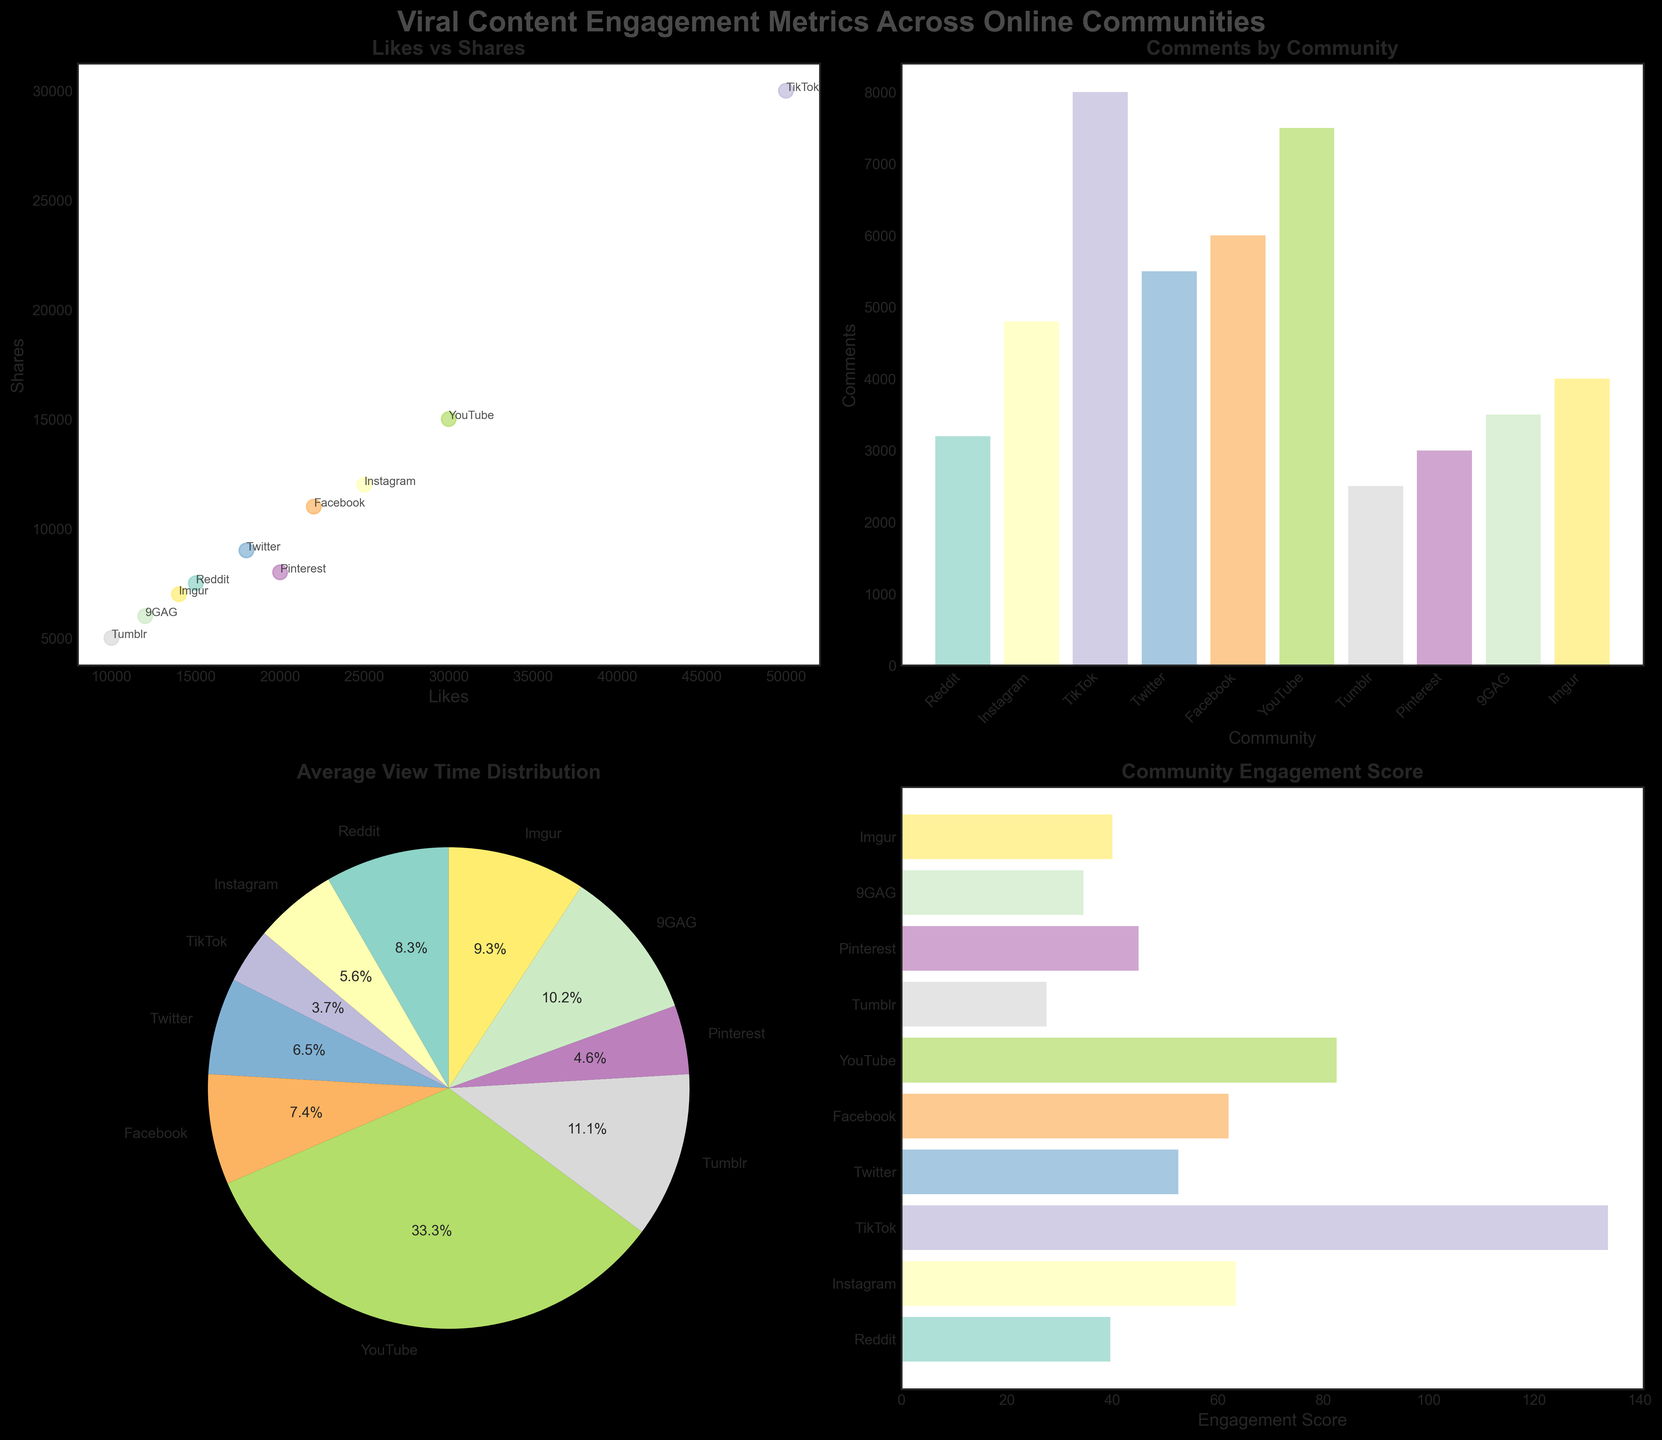How many communities are represented in these plots? By counting the distinct labels on the x-axis of the bar charts or the labels on the pie chart, we can identify the number of communities represented in the figure.
Answer: 10 Which community has the highest number of likes? Referring to the x-axis of the Likes vs Shares scatter plot, we see that TikTok has the highest number of likes, indicated by the farthest data point to the right.
Answer: TikTok Which subplot shows the average view time of each community? Observing the titles of each subplot, the one labeled "Average View Time Distribution" is a pie chart representing the average view time of each community.
Answer: The pie chart in the bottom-left How many comments does Pinterest have? Looking at the Comments by Community bar chart, we find Pinterest labeled on the x-axis and the corresponding bar height gives the value.
Answer: 3000 What is the engagement score of Facebook? Engagement score is calculated using the formula (Likes + Shares * 2 + Comments * 3) / 1000. For Facebook, the values are 22000 likes, 11000 shares, and 6000 comments. So, (22000 + 11000*2 + 6000*3) / 1000 = (22000 + 22000 + 18000) / 1000 = 62000 / 1000 = 62.
Answer: 62 Which community has the second largest engagement score? Looking at the Community Engagement Score subplot and identifying the second tallest bar, Reddit follows TikTok in terms of engagement score.
Answer: YouTube Is the average view time of YouTube greater than the combined average view times of TikTok and Instagram? From the pie chart, YouTube has 180 seconds, and the combined view time of TikTok and Instagram are 20 and 30 seconds respectively. 180 > (20 + 30) is true.
Answer: Yes Which community has more shares, Reddit or Twitter? From the Likes vs Shares scatter plot, comparing the points annotated with Reddit and Twitter, Twitter has a higher position on the y-axis (Shares).
Answer: Twitter How does the number of shares on Reddit compare to the number of comments on Facebook? Referring to the scatter plot and comments bar chart, Reddit has 7500 shares and Facebook has 6000 comments. 7500 > 6000.
Answer: More shares on Reddit Which community has the largest slice in the Average View Time pie chart? The community with the largest percentage label in the pie chart is YouTube.
Answer: YouTube 